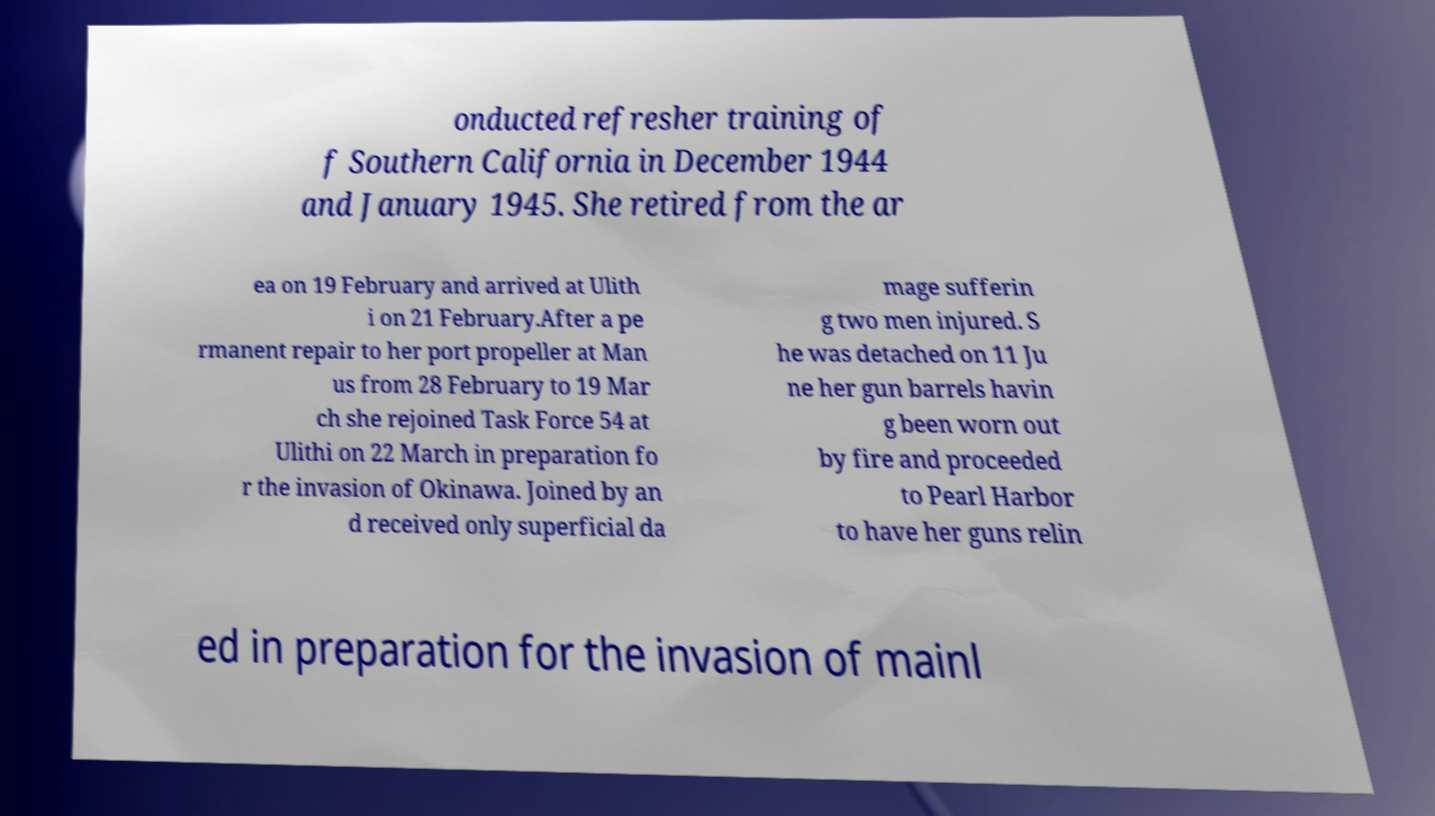Can you accurately transcribe the text from the provided image for me? onducted refresher training of f Southern California in December 1944 and January 1945. She retired from the ar ea on 19 February and arrived at Ulith i on 21 February.After a pe rmanent repair to her port propeller at Man us from 28 February to 19 Mar ch she rejoined Task Force 54 at Ulithi on 22 March in preparation fo r the invasion of Okinawa. Joined by an d received only superficial da mage sufferin g two men injured. S he was detached on 11 Ju ne her gun barrels havin g been worn out by fire and proceeded to Pearl Harbor to have her guns relin ed in preparation for the invasion of mainl 